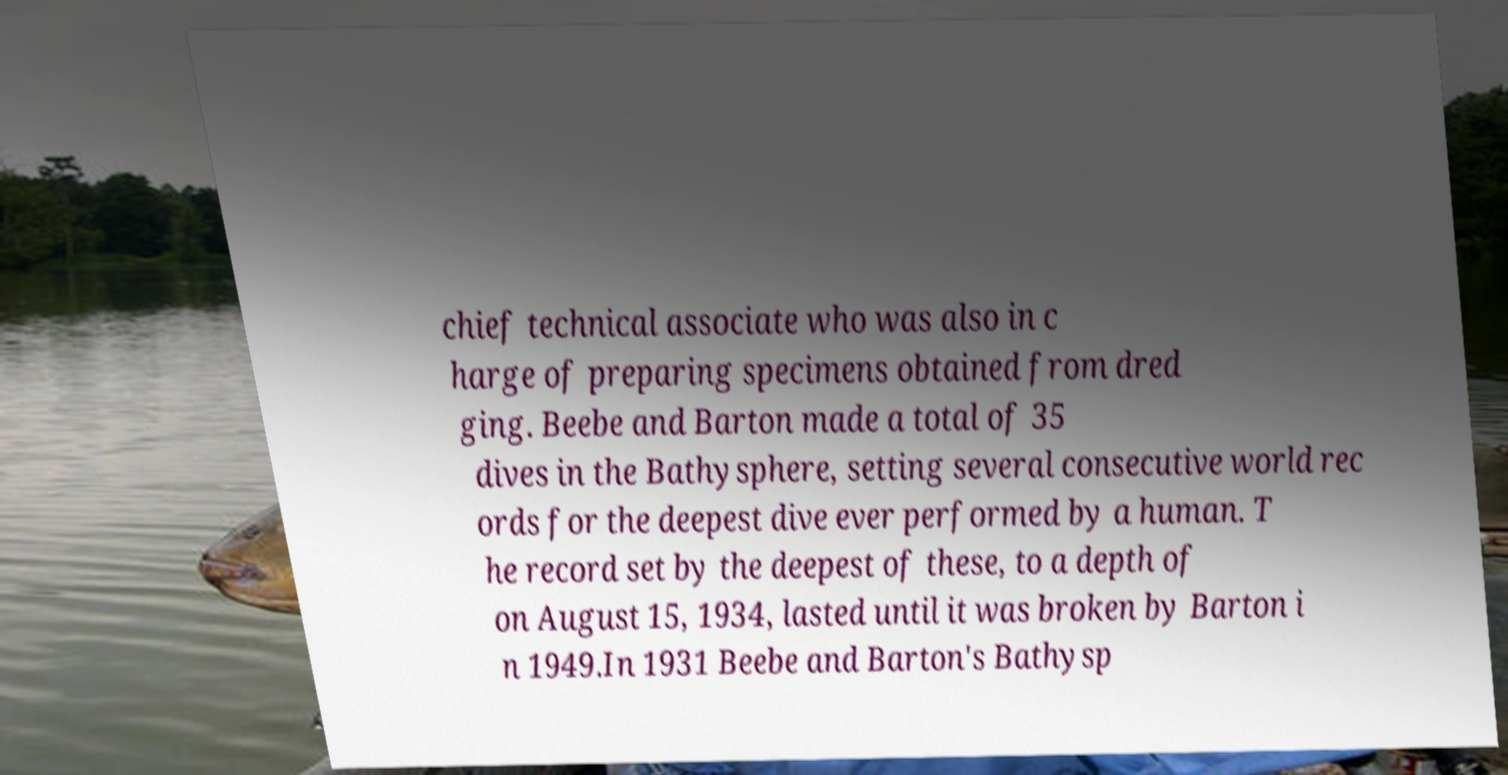Can you read and provide the text displayed in the image?This photo seems to have some interesting text. Can you extract and type it out for me? chief technical associate who was also in c harge of preparing specimens obtained from dred ging. Beebe and Barton made a total of 35 dives in the Bathysphere, setting several consecutive world rec ords for the deepest dive ever performed by a human. T he record set by the deepest of these, to a depth of on August 15, 1934, lasted until it was broken by Barton i n 1949.In 1931 Beebe and Barton's Bathysp 